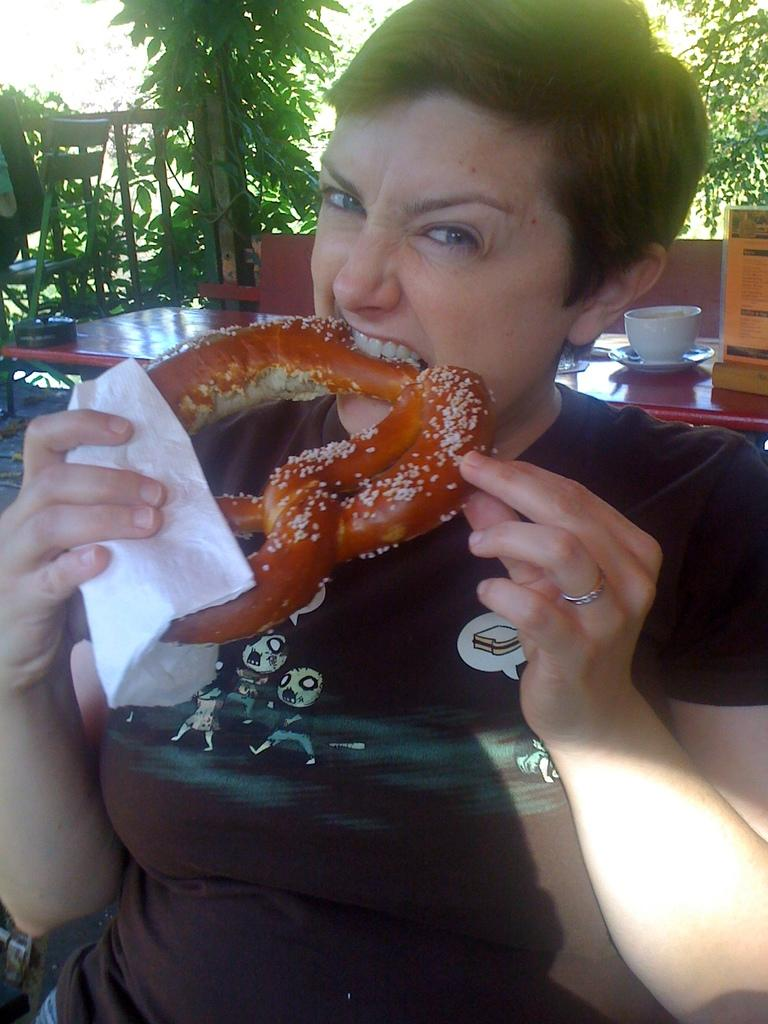Who is present in the image? There is a woman in the image. What is the woman holding in the image? The woman is holding a food item. What piece of furniture can be seen in the image? There is a table and a chair in the image. What is on the table in the image? There is a teacup on the table. What type of vegetation is present in the image? There is a plant in the image. How far is the sidewalk from the woman in the image? There is no sidewalk present in the image. 